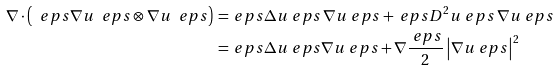Convert formula to latex. <formula><loc_0><loc_0><loc_500><loc_500>\nabla \cdot \left ( \ e p s \nabla u _ { \ } e p s \otimes \nabla u _ { \ } e p s \right ) \, = \, & \ e p s \Delta u _ { \ } e p s \, \nabla u _ { \ } e p s + \ e p s D ^ { 2 } u _ { \ } e p s \, \nabla u _ { \ } e p s \\ = \, & \ e p s \Delta u _ { \ } e p s \nabla u _ { \ } e p s + \nabla \frac { \ e p s } { 2 } \left | \nabla u _ { \ } e p s \right | ^ { 2 }</formula> 